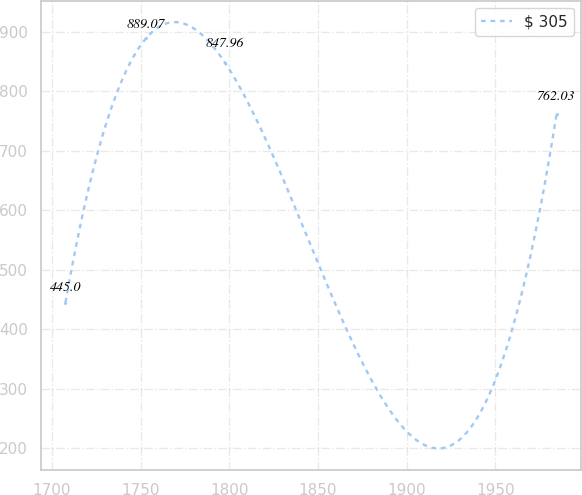Convert chart. <chart><loc_0><loc_0><loc_500><loc_500><line_chart><ecel><fcel>$ 305<nl><fcel>1707.7<fcel>445<nl><fcel>1753.19<fcel>889.07<nl><fcel>1797.57<fcel>847.96<nl><fcel>1984.46<fcel>762.03<nl></chart> 